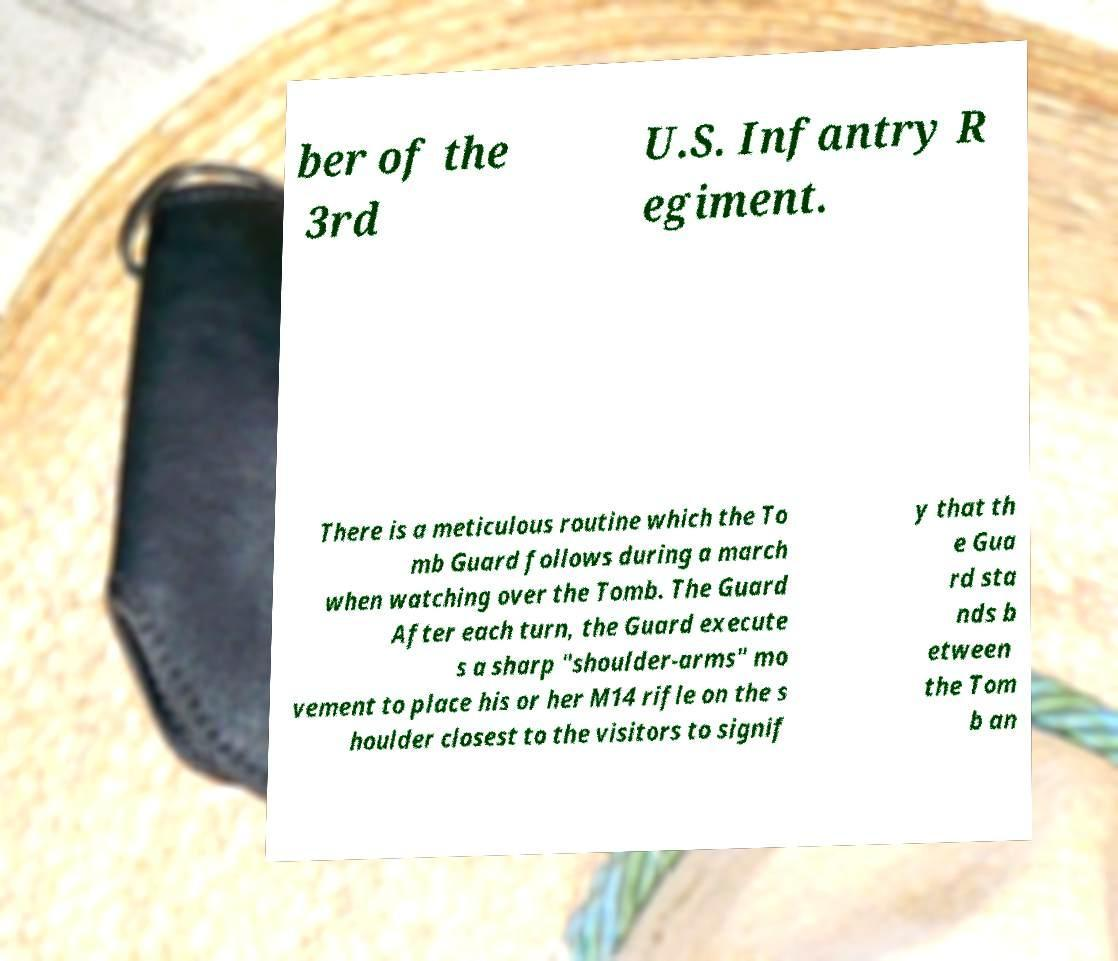I need the written content from this picture converted into text. Can you do that? ber of the 3rd U.S. Infantry R egiment. There is a meticulous routine which the To mb Guard follows during a march when watching over the Tomb. The Guard After each turn, the Guard execute s a sharp "shoulder-arms" mo vement to place his or her M14 rifle on the s houlder closest to the visitors to signif y that th e Gua rd sta nds b etween the Tom b an 